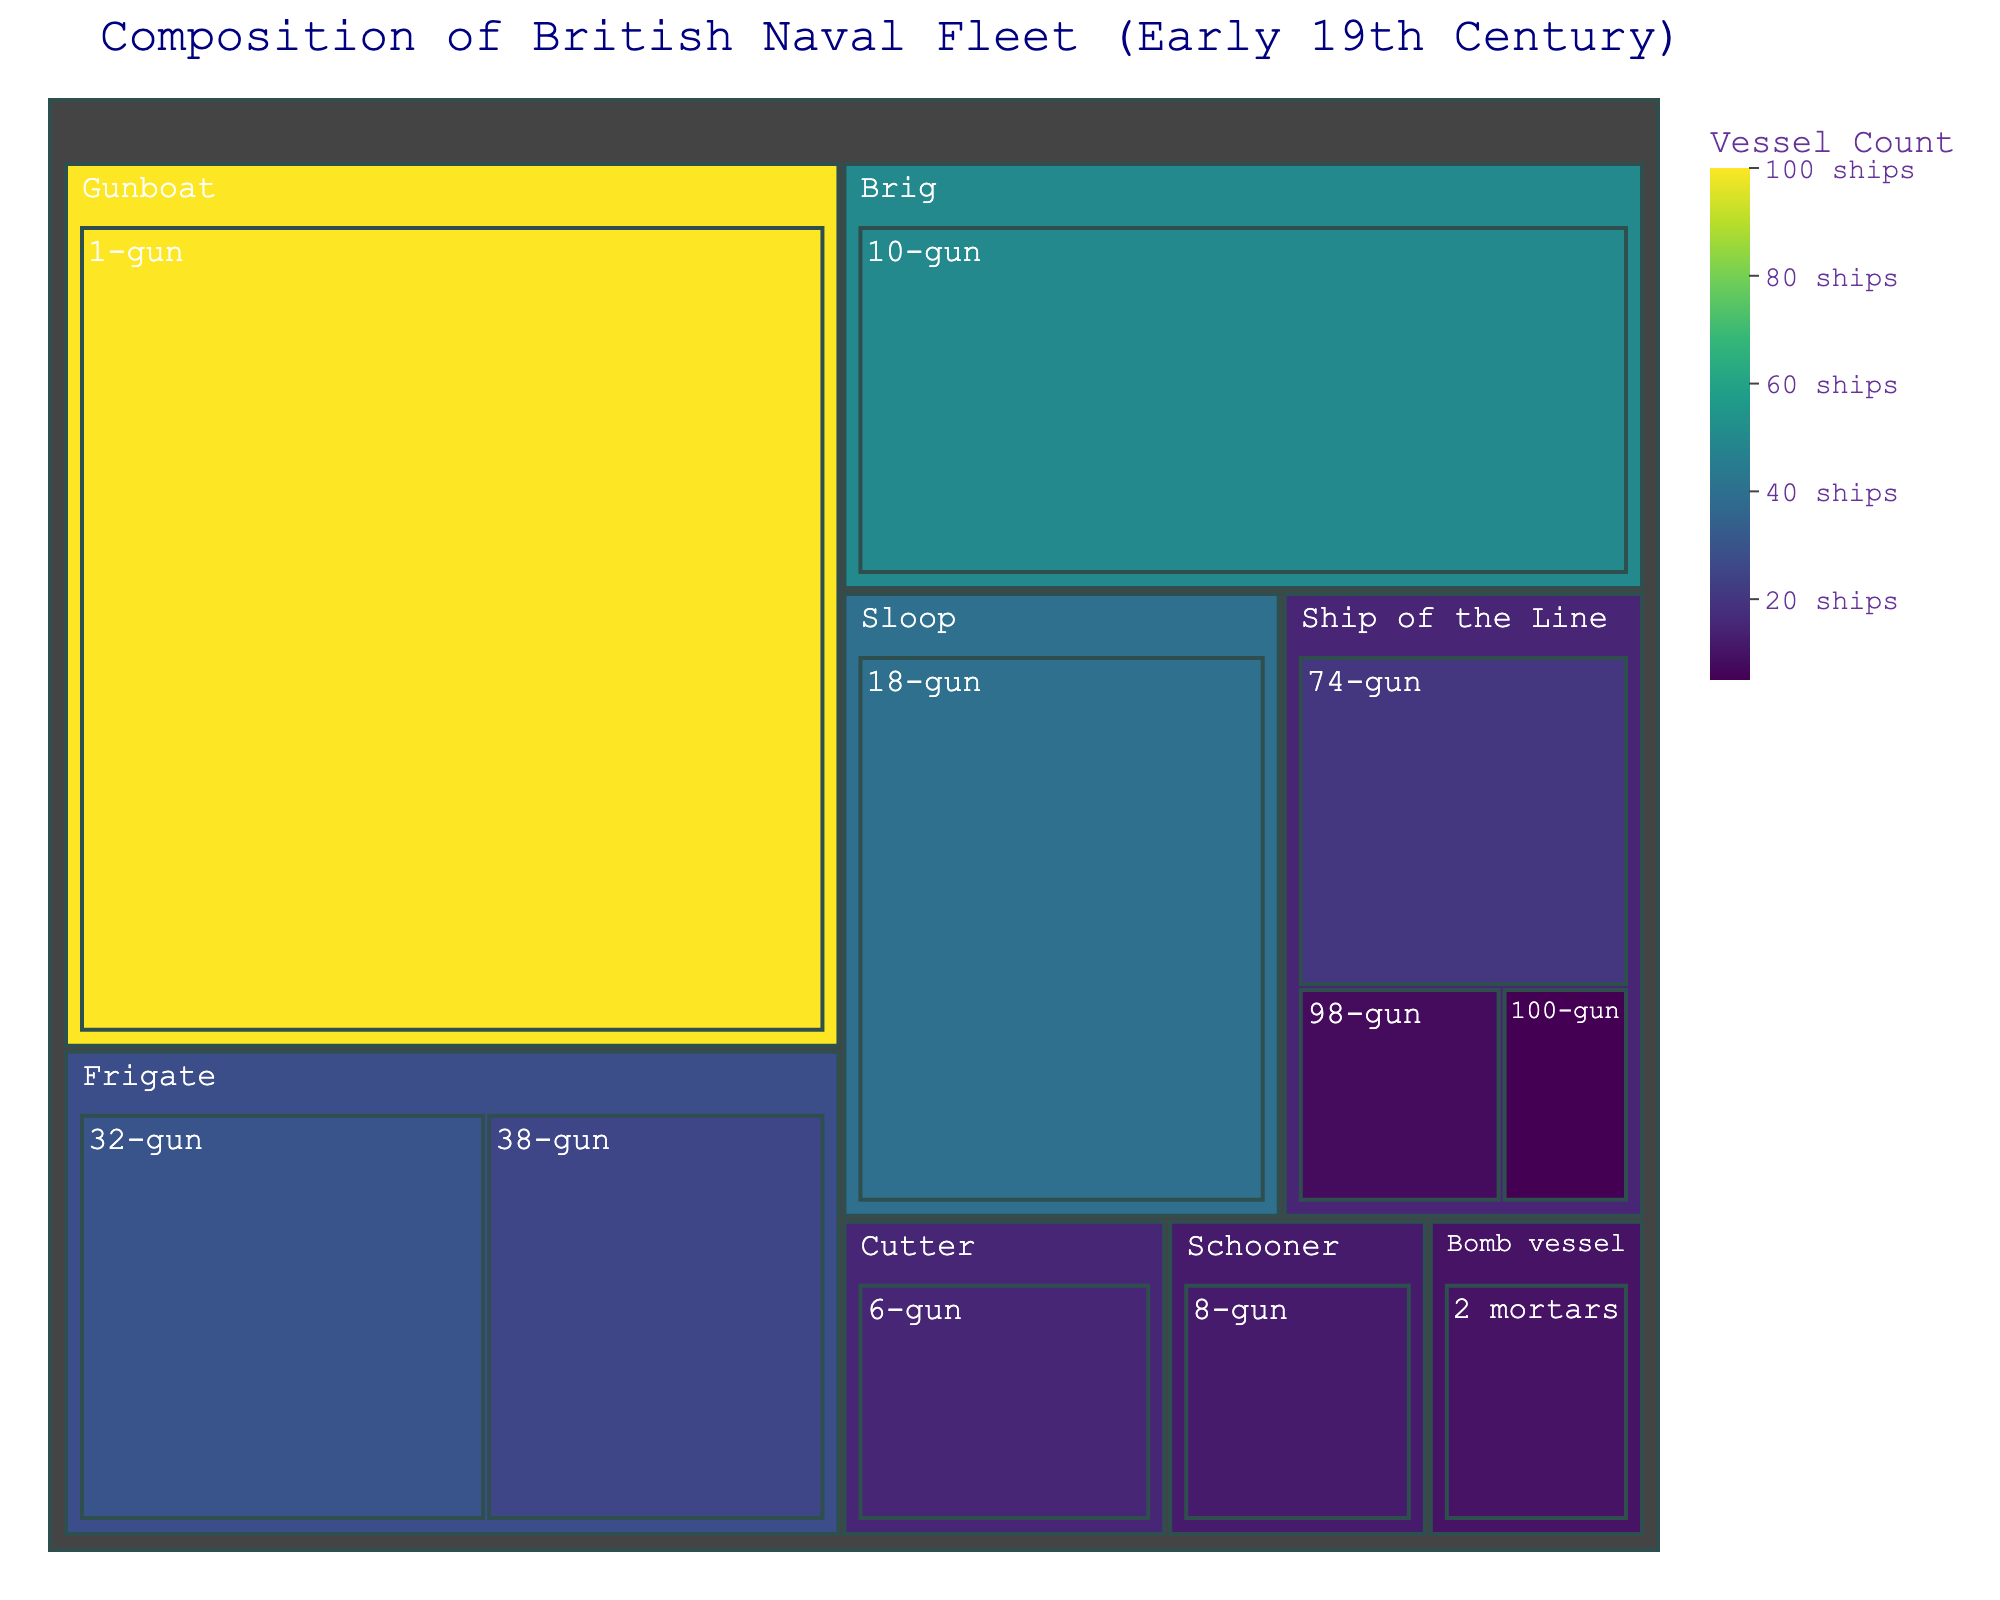What is the title of the treemap? Look at the main heading of the treemap to determine the title.
Answer: Composition of British Naval Fleet (Early 19th Century) Which vessel type has the highest number of vessels? Check the area of each main section in the treemap; the largest represents the highest count.
Answer: Gunboat How many 74-gun Ships of the Line are there? Find the section for Ships of the Line and identify the subsection labeled '74-gun.' The count is displayed there.
Answer: 20 What is the total number of Ships of the Line? Sum the counts of all Ship of the Line subsections: 74-gun, 98-gun, and 100-gun. 20 + 8 + 5 = 33
Answer: 33 Which vessel type has more 38-gun or 32-gun vessels? Compare the sizes and labels of the 38-gun Frigate and the 32-gun Frigate sections.
Answer: 32-gun How many more 18-gun Sloops are there compared to 8-gun Schooners? Subtract the count of Schooners from Sloops: 40 (Sloops) - 12 (Schooners) = 28
Answer: 28 What proportion of the fleet is composed of Gunboats? Find the count of Gunboats and the total number of vessels in the fleet, then divide and multiply by 100: (100 / 315) * 100 ≈ 31.75%
Answer: ~31.75% Which vessel type has the least number of vessels? Identify the smallest section of the treemap.
Answer: Bomb vessel Which vessel type and armament combination is the least common? Identify the smallest subsection within any vessel type by count.
Answer: Bomb vessel, 2 mortars What vessel type has more than 10 vessels but fewer than 20? Look for sections where the count falls between 10 and 20 by interpreting the size and labels.
Answer: Cutter 